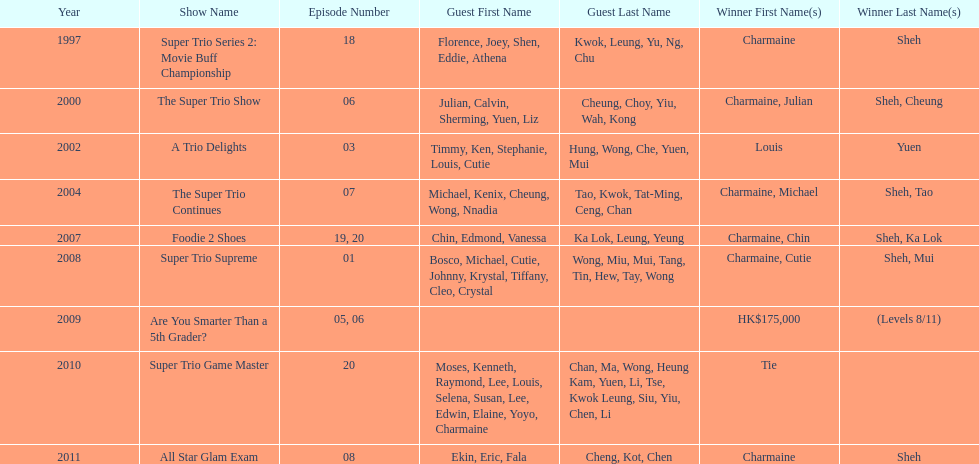Could you help me parse every detail presented in this table? {'header': ['Year', 'Show Name', 'Episode Number', 'Guest First Name', 'Guest Last Name', 'Winner First Name(s)', 'Winner Last Name(s)'], 'rows': [['1997', 'Super Trio Series 2: Movie Buff Championship', '18', 'Florence, Joey, Shen, Eddie, Athena', 'Kwok, Leung, Yu, Ng, Chu', 'Charmaine', 'Sheh'], ['2000', 'The Super Trio Show', '06', 'Julian, Calvin, Sherming, Yuen, Liz', 'Cheung, Choy, Yiu, Wah, Kong', 'Charmaine, Julian', 'Sheh, Cheung'], ['2002', 'A Trio Delights', '03', 'Timmy, Ken, Stephanie, Louis, Cutie', 'Hung, Wong, Che, Yuen, Mui', 'Louis', 'Yuen'], ['2004', 'The Super Trio Continues', '07', 'Michael, Kenix, Cheung, Wong, Nnadia', 'Tao, Kwok, Tat-Ming, Ceng, Chan', 'Charmaine, Michael', 'Sheh, Tao'], ['2007', 'Foodie 2 Shoes', '19, 20', 'Chin, Edmond, Vanessa', 'Ka Lok, Leung, Yeung', 'Charmaine, Chin', 'Sheh, Ka Lok'], ['2008', 'Super Trio Supreme', '01', 'Bosco, Michael, Cutie, Johnny, Krystal, Tiffany, Cleo, Crystal', 'Wong, Miu, Mui, Tang, Tin, Hew, Tay, Wong', 'Charmaine, Cutie', 'Sheh, Mui'], ['2009', 'Are You Smarter Than a 5th Grader?', '05, 06', '', '', 'HK$175,000', '(Levels 8/11)'], ['2010', 'Super Trio Game Master', '20', 'Moses, Kenneth, Raymond, Lee, Louis, Selena, Susan, Lee, Edwin, Elaine, Yoyo, Charmaine', 'Chan, Ma, Wong, Heung Kam, Yuen, Li, Tse, Kwok Leung, Siu, Yiu, Chen, Li', 'Tie', ''], ['2011', 'All Star Glam Exam', '08', 'Ekin, Eric, Fala', 'Cheng, Kot, Chen', 'Charmaine', 'Sheh']]} How many times has charmaine sheh won on a variety show? 6. 